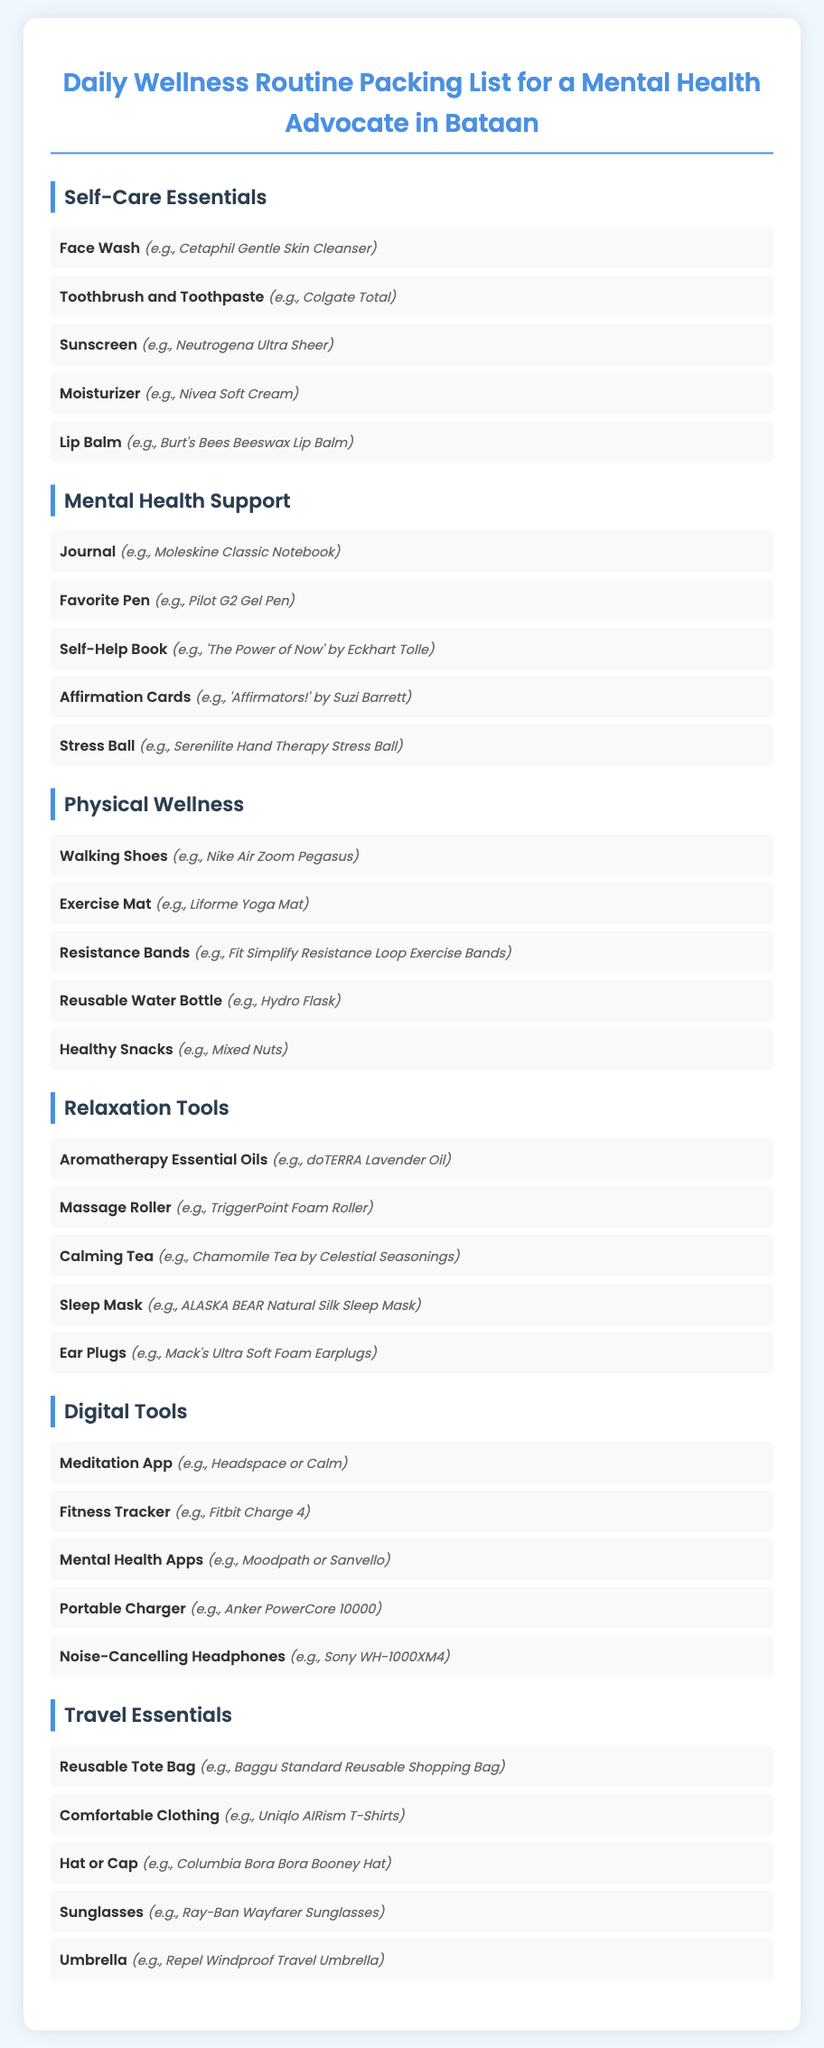What is the first item in the Self-Care Essentials category? The first item listed under Self-Care Essentials is Face Wash.
Answer: Face Wash Which brand of lip balm is mentioned? Burt's Bees Beeswax Lip Balm is the example given for lip balm under Self-Care Essentials.
Answer: Burt's Bees Beeswax Lip Balm How many items are listed under Mental Health Support? There are five items listed under the Mental Health Support category.
Answer: 5 What type of shoes are recommended for Physical Wellness? The item recommended is Walking Shoes.
Answer: Walking Shoes Which relaxation tool is an example of aromatherapy? doTERRA Lavender Oil is the aromatherapy example provided.
Answer: doTERRA Lavender Oil What is the suggested reusable bag in the Travel Essentials section? Baggu Standard Reusable Shopping Bag is mentioned as an example of a reusable tote bag.
Answer: Baggu Standard Reusable Shopping Bag Which meditation app is recommended in the Digital Tools category? The document mentions Headspace or Calm as meditation apps.
Answer: Headspace or Calm What should you carry for hydration during physical activities? A Reusable Water Bottle is suggested for hydration.
Answer: Reusable Water Bottle Which essential item helps with stress in the Mental Health Support category? A Stress Ball is listed as a helpful item for managing stress.
Answer: Stress Ball 